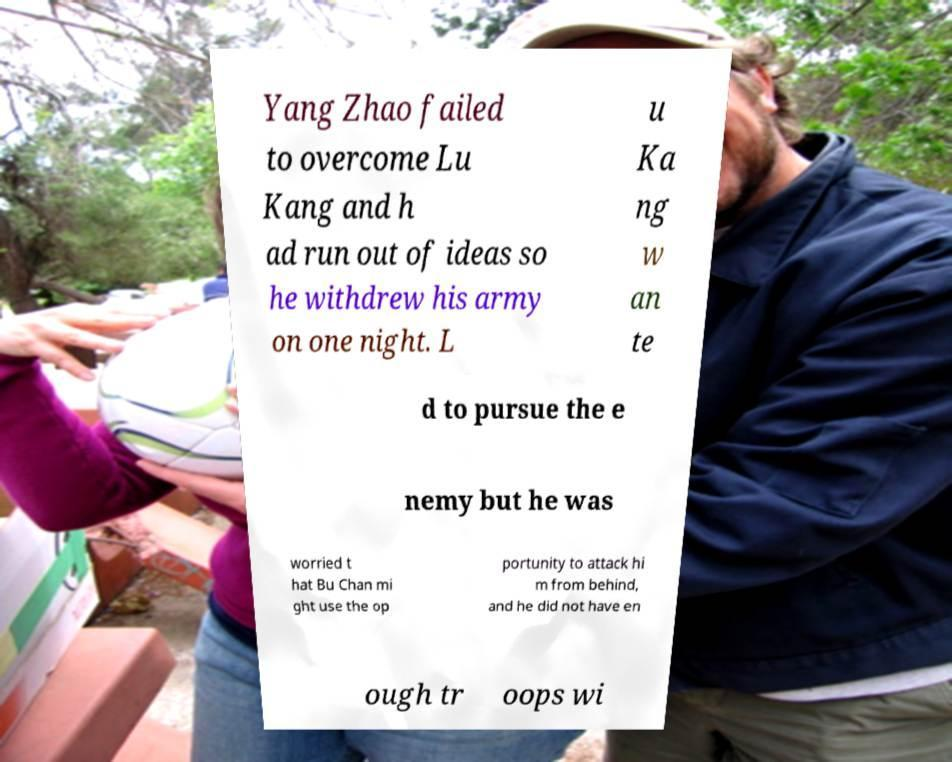I need the written content from this picture converted into text. Can you do that? Yang Zhao failed to overcome Lu Kang and h ad run out of ideas so he withdrew his army on one night. L u Ka ng w an te d to pursue the e nemy but he was worried t hat Bu Chan mi ght use the op portunity to attack hi m from behind, and he did not have en ough tr oops wi 